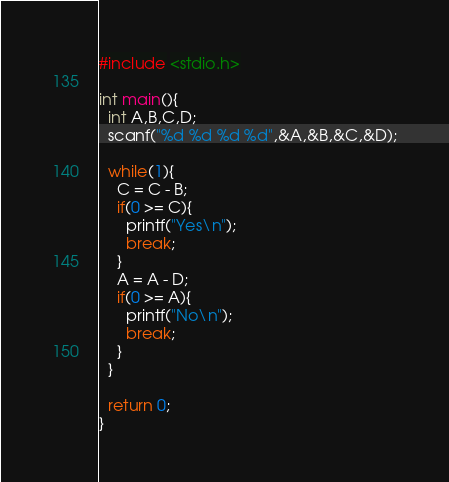<code> <loc_0><loc_0><loc_500><loc_500><_C_>#include <stdio.h>

int main(){
  int A,B,C,D;
  scanf("%d %d %d %d",&A,&B,&C,&D);
  
  while(1){
	C = C - B;
    if(0 >= C){
	  printf("Yes\n");
      break;
    }
    A = A - D;
    if(0 >= A){
	  printf("No\n");
      break;
    }
  }
  
  return 0;
}</code> 